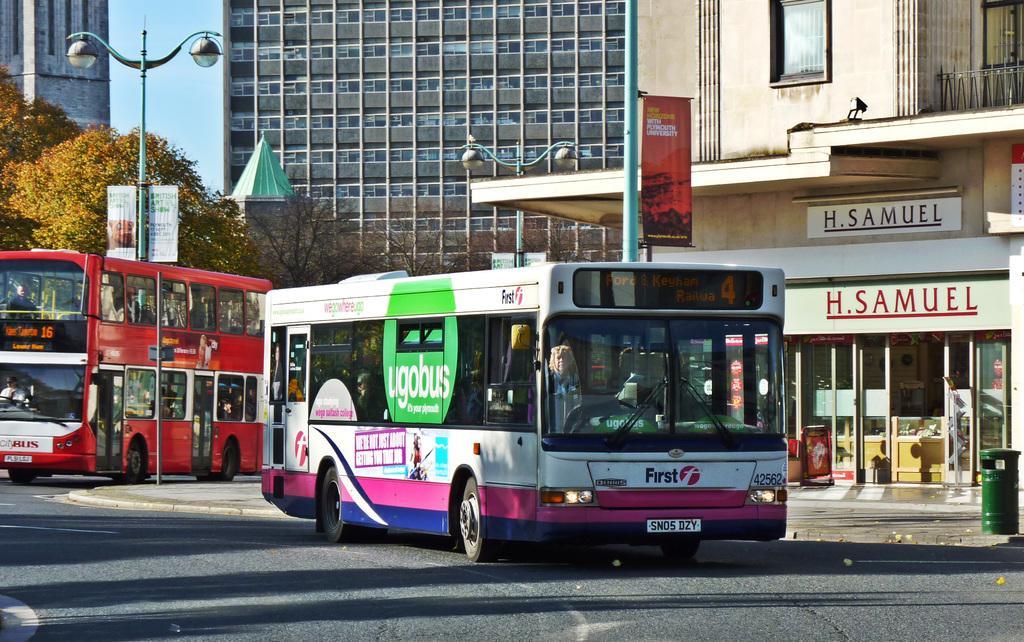Could you give a brief overview of what you see in this image? Picture of a city. Vehicles are travelling on road. Far there are buildings with windows. Pole with light. Banners are attached with the pole. Far there is a tree and bare trees. This is a store with door. In-front of this store there is a green color bin. This is a double decker bus. 